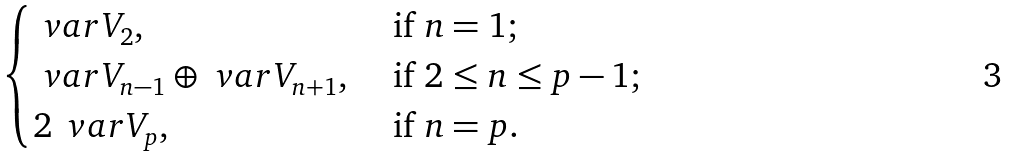<formula> <loc_0><loc_0><loc_500><loc_500>\begin{cases} \ v a r { V } _ { 2 } , & \text { if } n = 1 ; \\ \ v a r { V } _ { n - 1 } \oplus \ v a r { V } _ { n + 1 } , & \text { if } 2 \leq n \leq p - 1 ; \\ 2 \, \ v a r { V } _ { p } , & \text { if } n = p . \end{cases}</formula> 